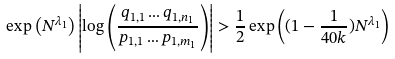Convert formula to latex. <formula><loc_0><loc_0><loc_500><loc_500>\exp \left ( N ^ { \lambda _ { 1 } } \right ) \left | \log \left ( \frac { q _ { 1 , 1 } \dots q _ { 1 , n _ { 1 } } } { p _ { 1 , 1 } \dots p _ { 1 , m _ { 1 } } } \right ) \right | > \frac { 1 } { 2 } \exp \left ( ( 1 - \frac { 1 } { 4 0 k } ) N ^ { \lambda _ { 1 } } \right )</formula> 